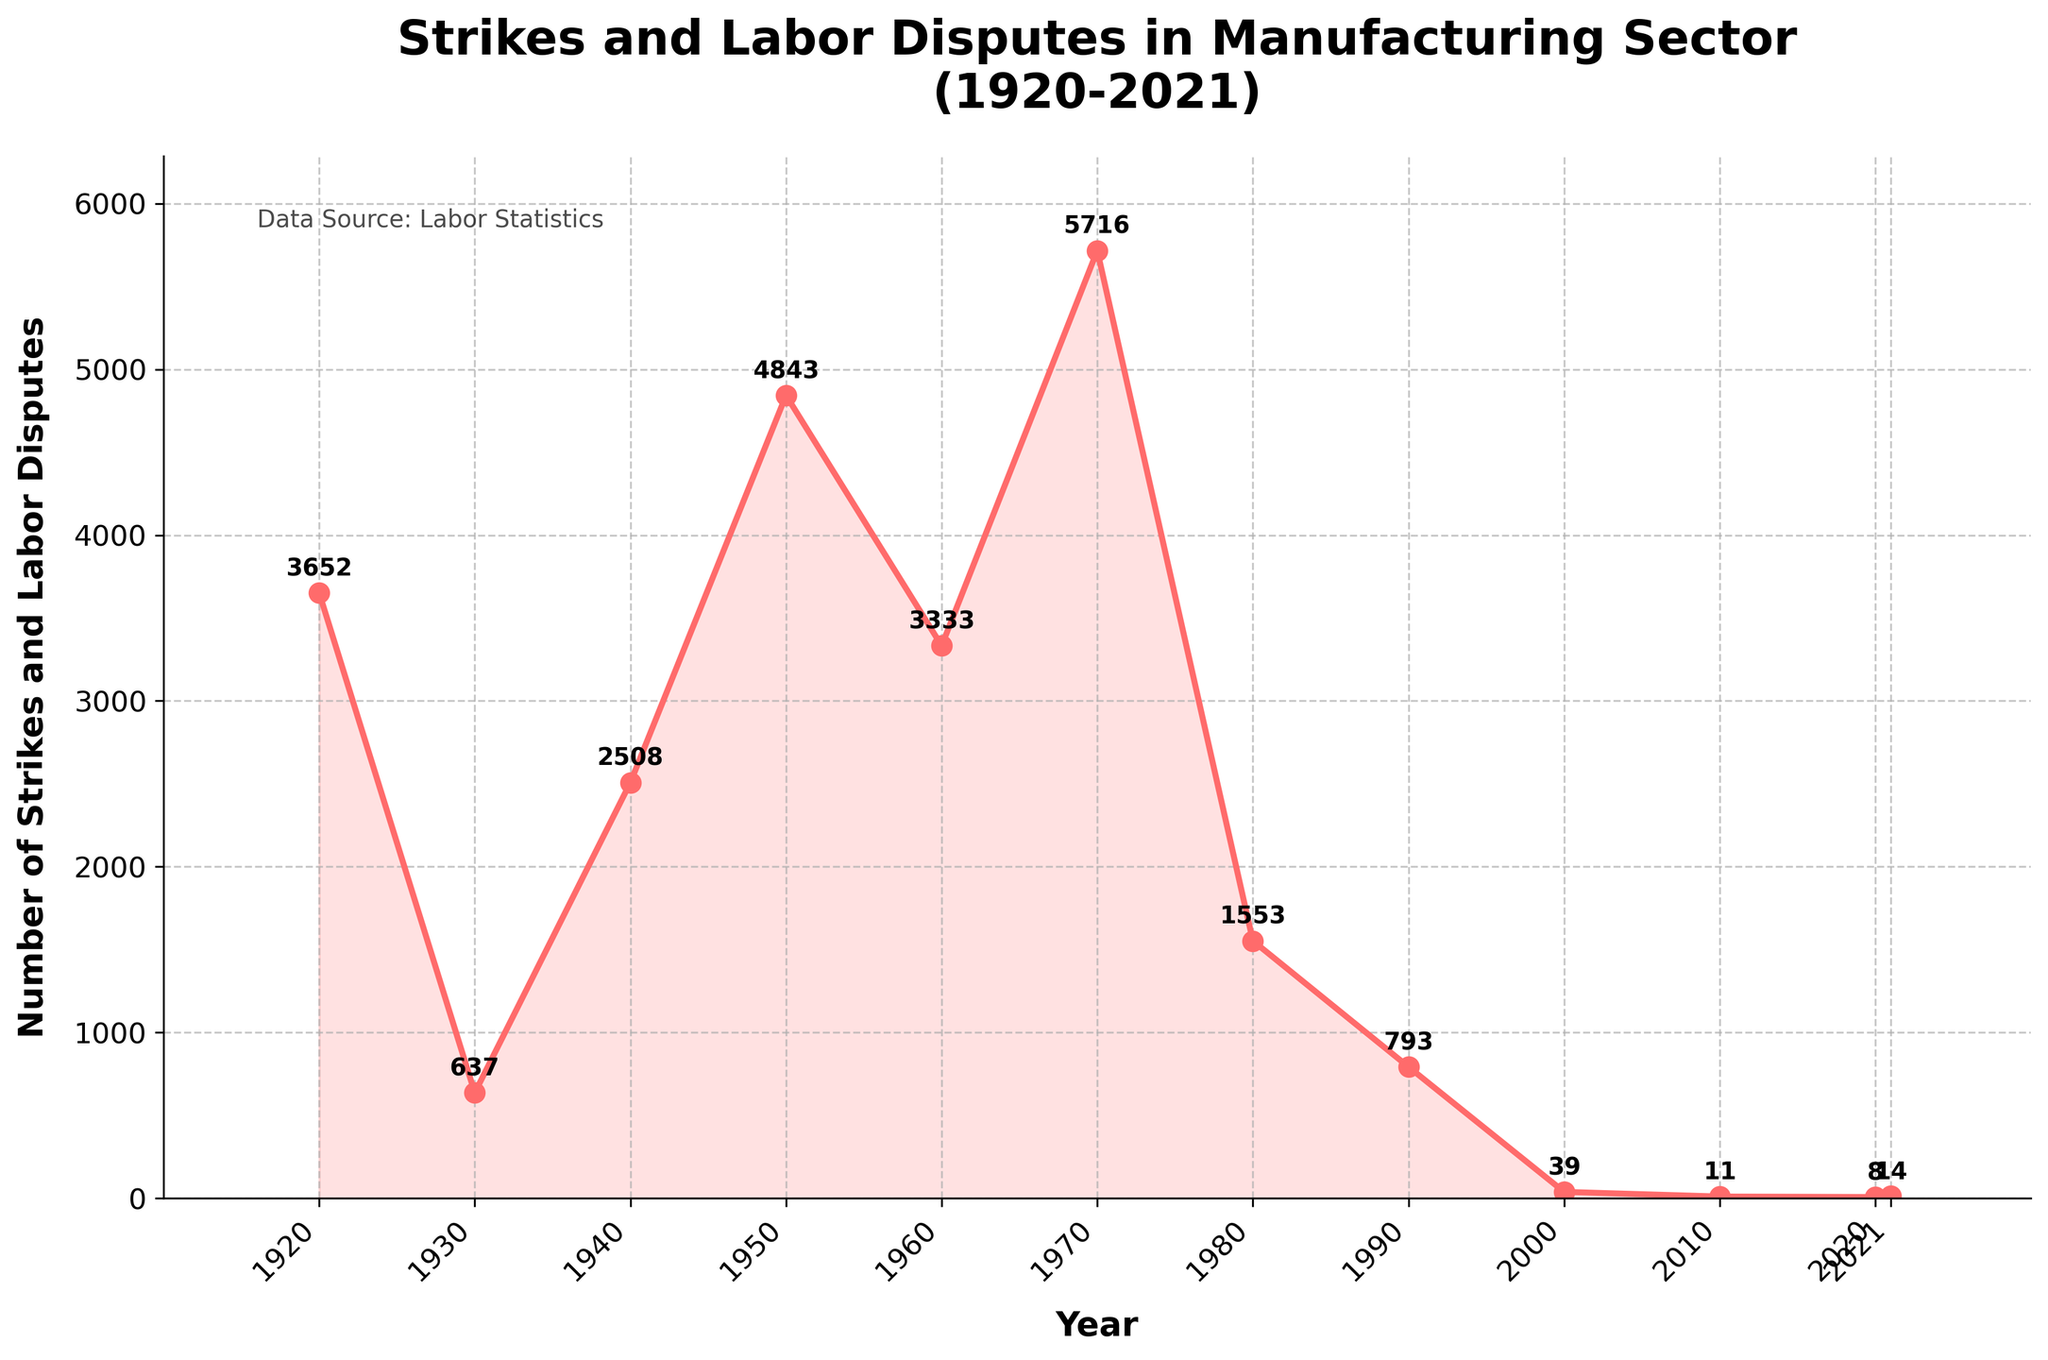Which year had the highest number of strikes and labor disputes? The year with the highest number of strikes can be observed from the peak of the plot. The highest point on the y-axis corresponds to 1970.
Answer: 1970 How many years had fewer than 100 strikes and labor disputes? Count the number of data points below the y-axis value of 100. Visual inspection shows only the years 2000, 2010, 2020, and 2021 fall below this threshold.
Answer: 4 What is the difference in the number of strikes and labor disputes between 1920 and 2020? Subtract the number of strikes in 2020 (8) from the number in 1920 (3652). Thus, 3652 - 8 = 3644.
Answer: 3644 What can we infer about the trend in strikes and labor disputes before and after 1970? Observing the plot, the trend shows an increase in strikes leading up to 1970, followed by a significant decrease post-1970.
Answer: Increased until 1970, then decreased On average, how many strikes and labor disputes occurred per decade from 1920 to 1980? Calculate the sum of strikes from 1920 to 1980 (3652 + 637 + 2508 + 4843 + 3333 + 5716 = 20689). Then divide by six decades. Thus, 20689 / 6 ≈ 3448.
Answer: Approximately 3448 Which years have the second and third lowest number of strikes and labor disputes? The plot shows the lowest in 2020 (8), the second lowest in 2010 (11), and the third lowest in 2021 (14).
Answer: 2010, 2021 How does the number of strikes in 1980 compare to that in 1950? Look at the respective data points: 1980 has 1553 strikes and 1950 has 4843 strikes. 1980 had fewer strikes.
Answer: 1980 had fewer Identify two adjacent decades where the difference in the number of strikes is the greatest. Calculate the differences between each adjacent decade: 1920-1930 (3015), 1930-1940 (1871), 1940-1950 (2335), 1950-1960 (1510), 1960-1970 (2383), 1970-1980 (4163). The greatest difference is between 1970 and 1980.
Answer: 1970-1980 